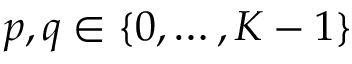Convert formula to latex. <formula><loc_0><loc_0><loc_500><loc_500>p , q \in \{ 0 , \dots , K - 1 \}</formula> 